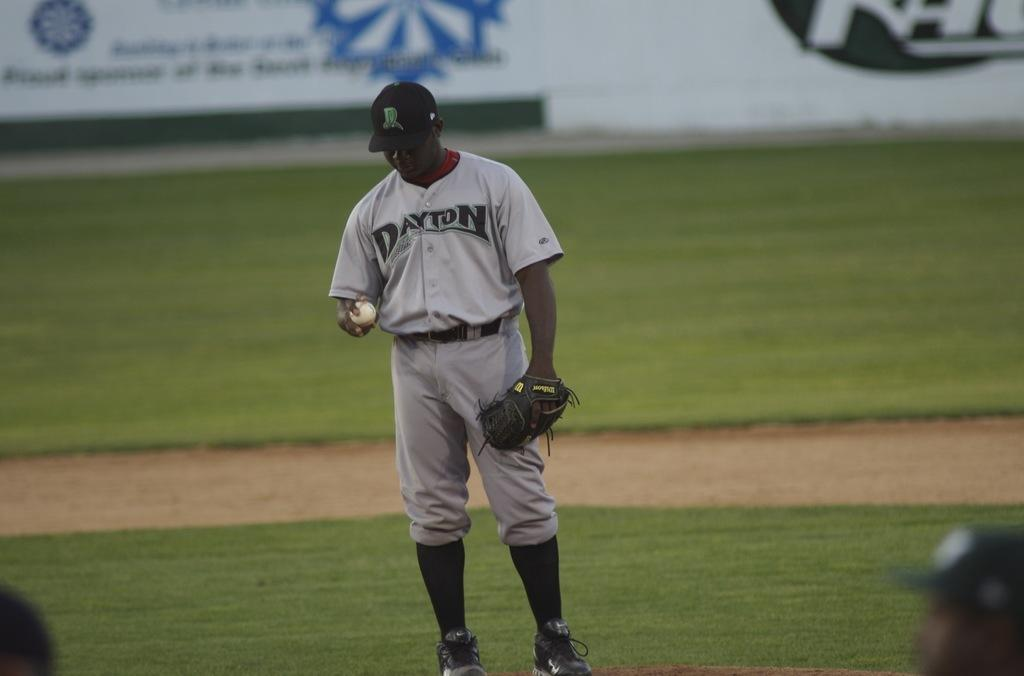Provide a one-sentence caption for the provided image. a Dayton baseball player looking at the baseball in his hand. 